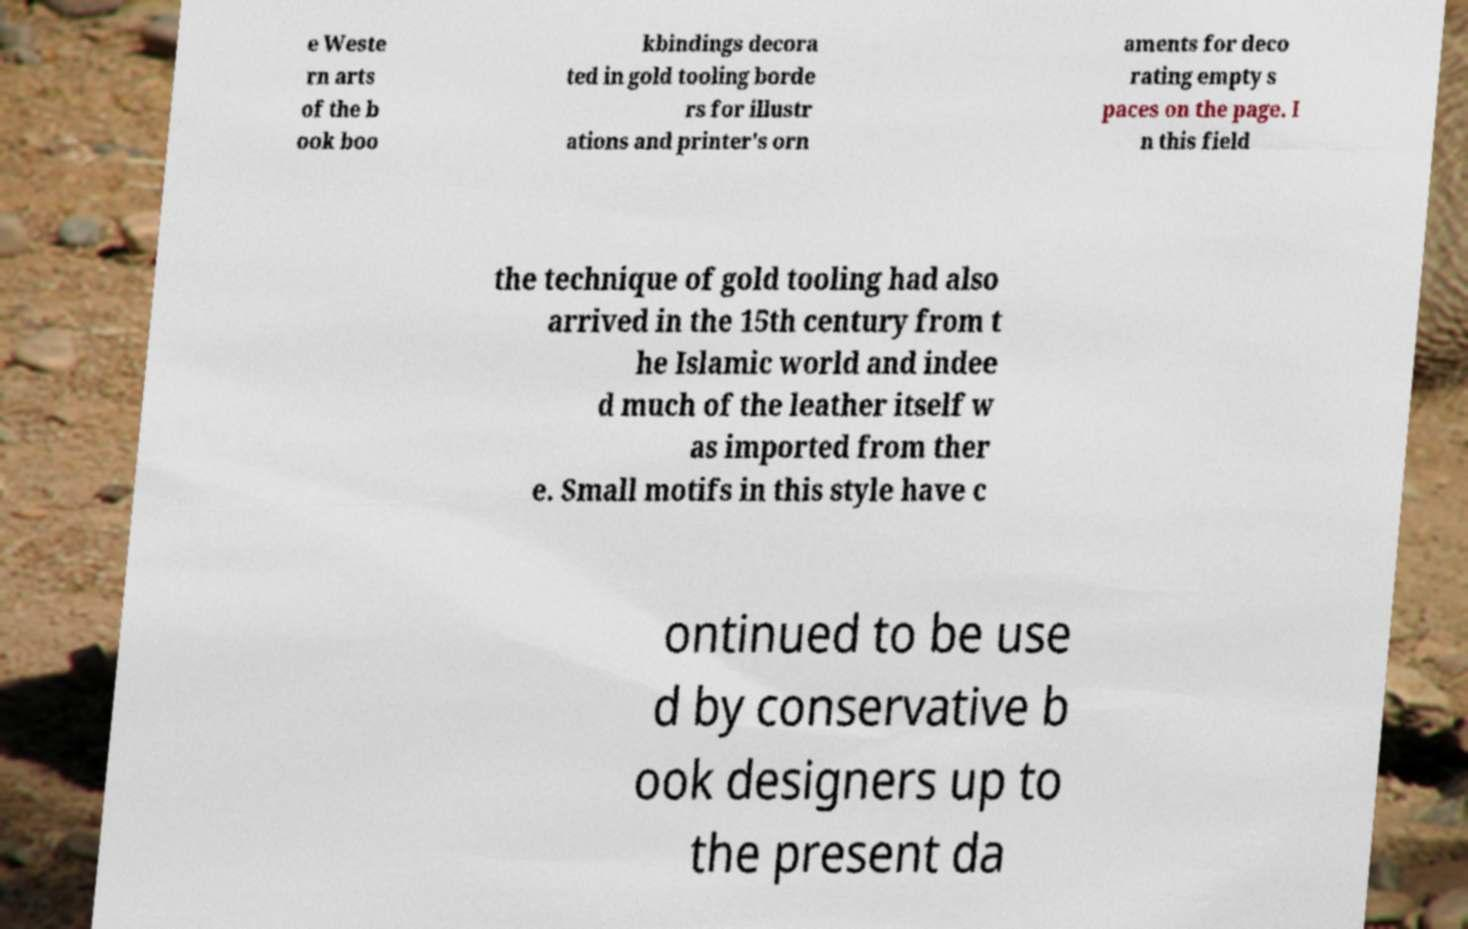There's text embedded in this image that I need extracted. Can you transcribe it verbatim? e Weste rn arts of the b ook boo kbindings decora ted in gold tooling borde rs for illustr ations and printer's orn aments for deco rating empty s paces on the page. I n this field the technique of gold tooling had also arrived in the 15th century from t he Islamic world and indee d much of the leather itself w as imported from ther e. Small motifs in this style have c ontinued to be use d by conservative b ook designers up to the present da 